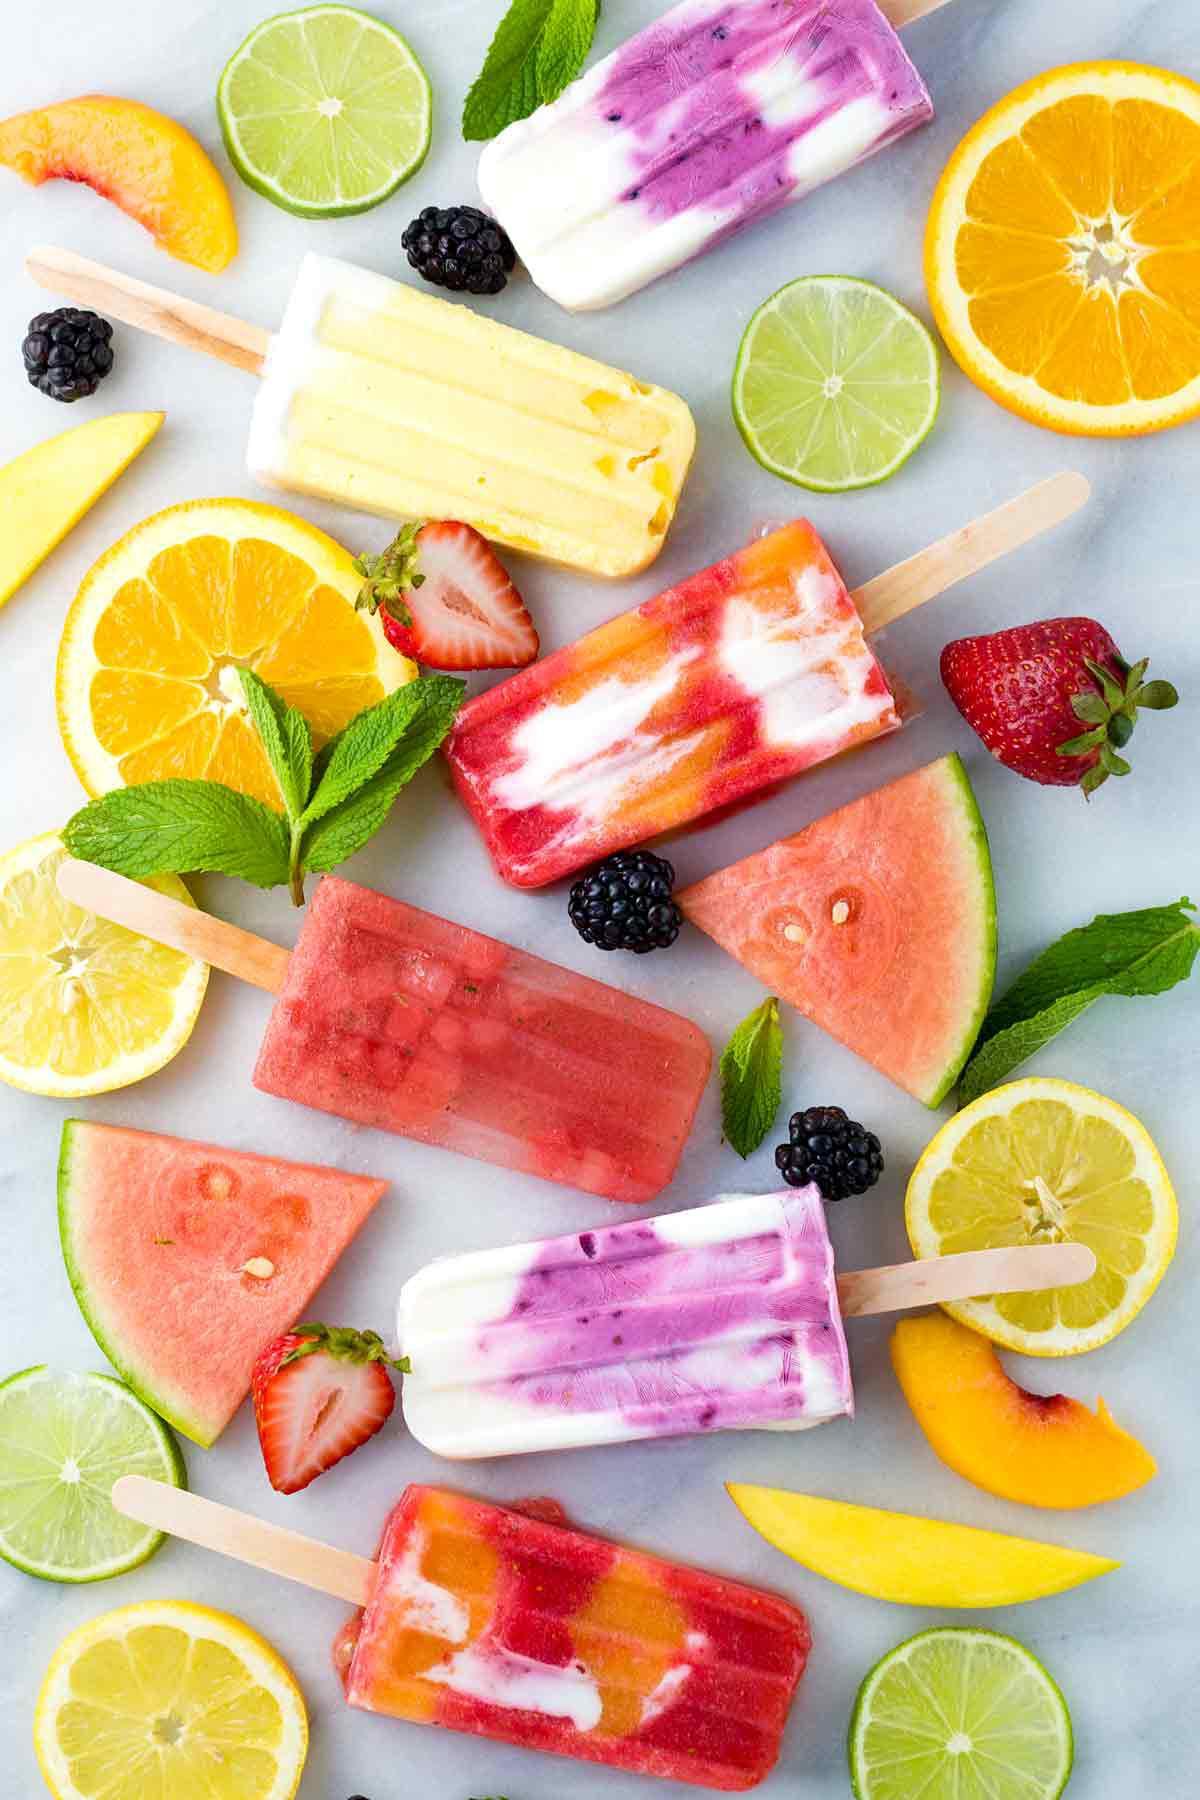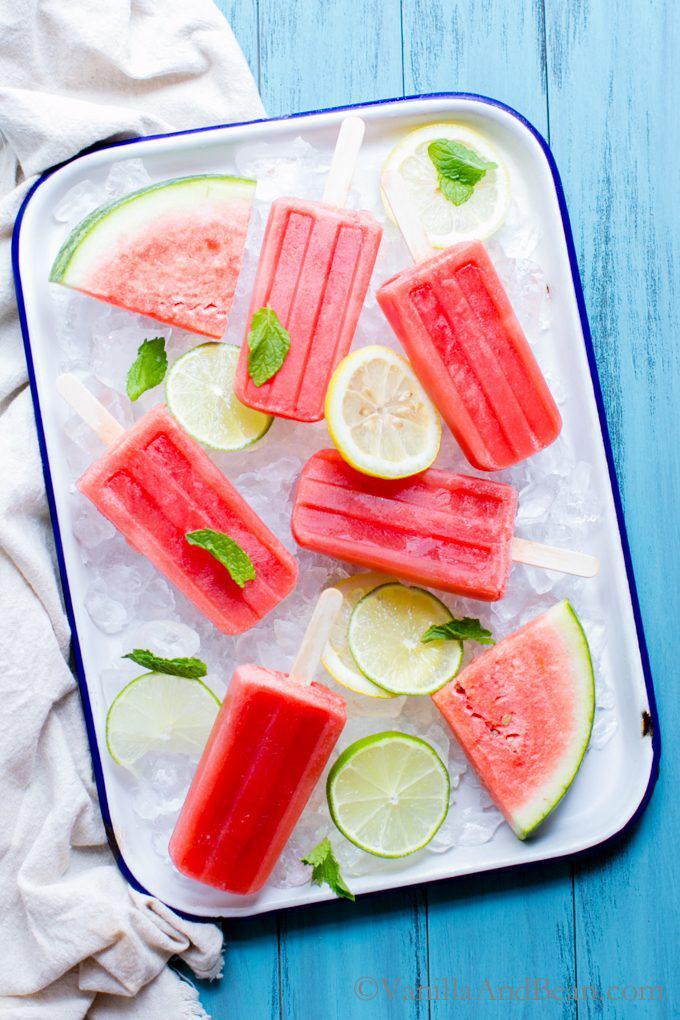The first image is the image on the left, the second image is the image on the right. For the images shown, is this caption "An image shows a whole lemon along with watermelon imagery." true? Answer yes or no. No. The first image is the image on the left, the second image is the image on the right. For the images shown, is this caption "Each of the images features fresh watermelon slices along with popsicles." true? Answer yes or no. Yes. 